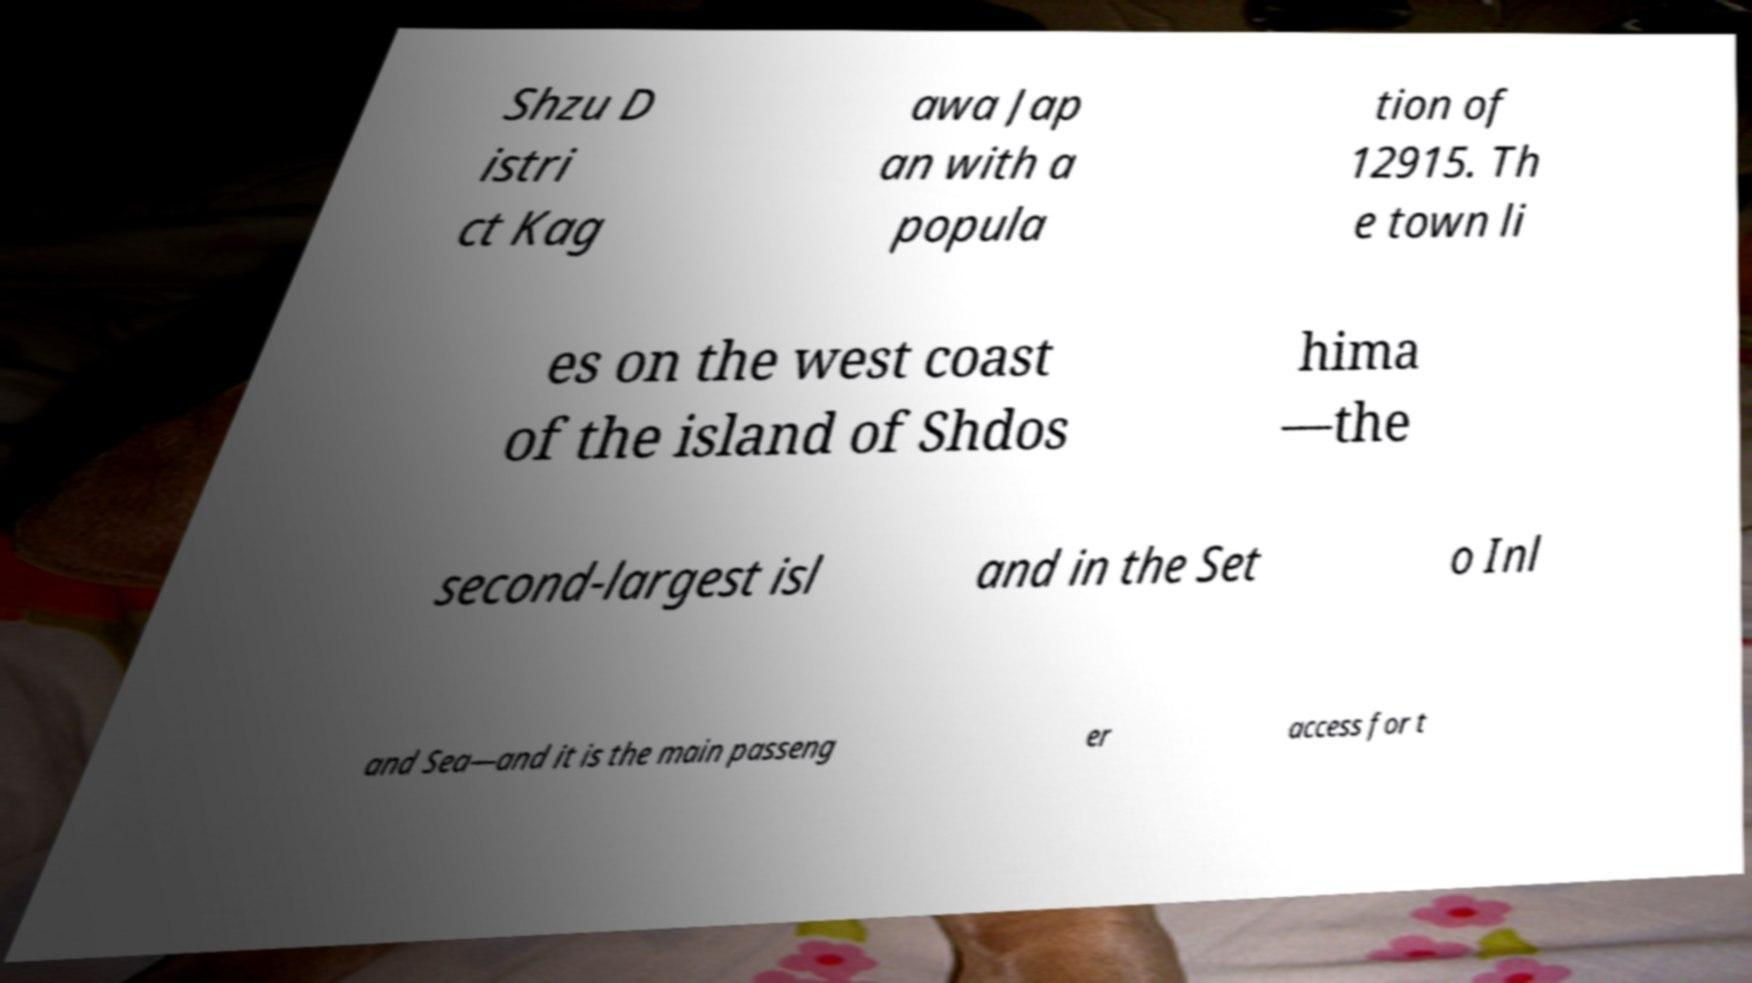Can you accurately transcribe the text from the provided image for me? Shzu D istri ct Kag awa Jap an with a popula tion of 12915. Th e town li es on the west coast of the island of Shdos hima —the second-largest isl and in the Set o Inl and Sea—and it is the main passeng er access for t 